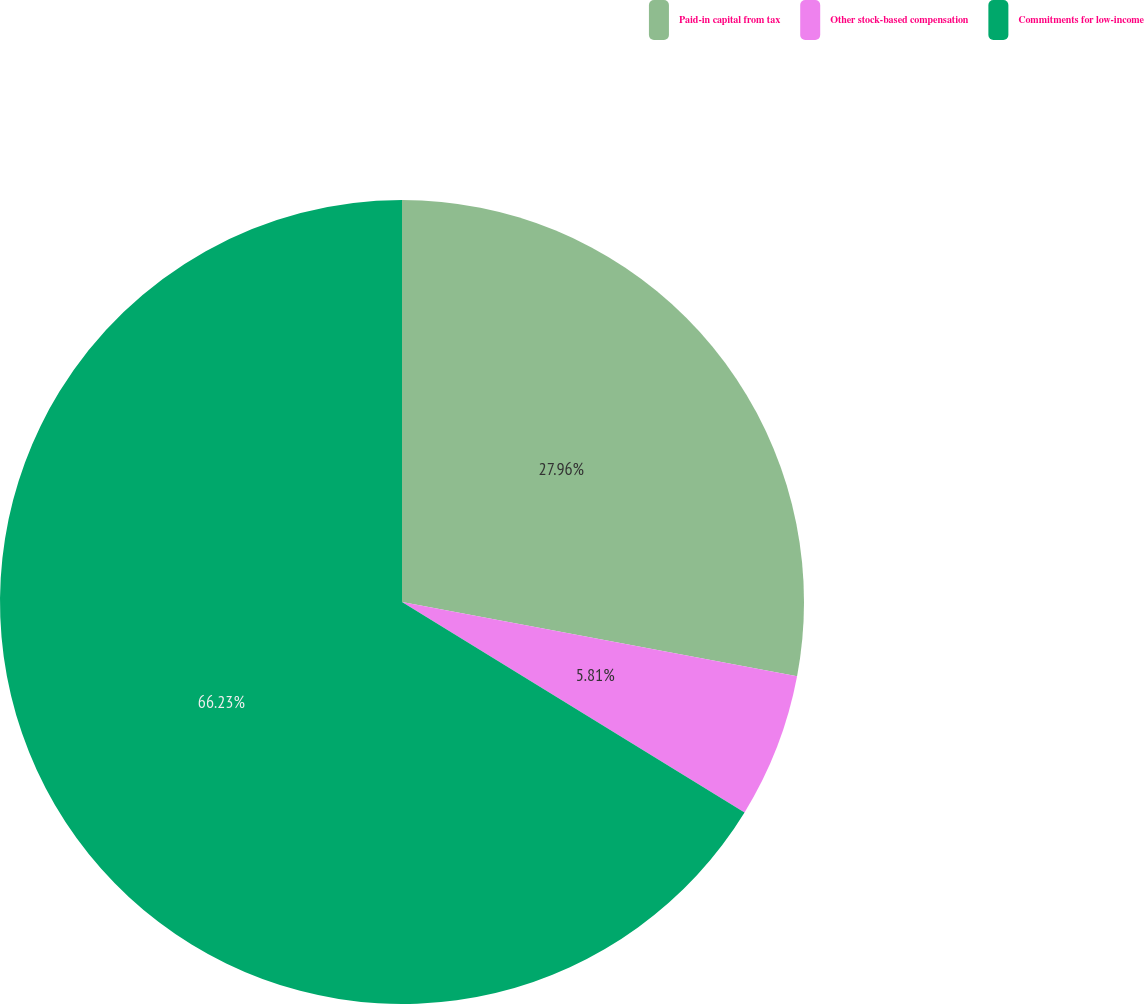Convert chart to OTSL. <chart><loc_0><loc_0><loc_500><loc_500><pie_chart><fcel>Paid-in capital from tax<fcel>Other stock-based compensation<fcel>Commitments for low-income<nl><fcel>27.96%<fcel>5.81%<fcel>66.24%<nl></chart> 